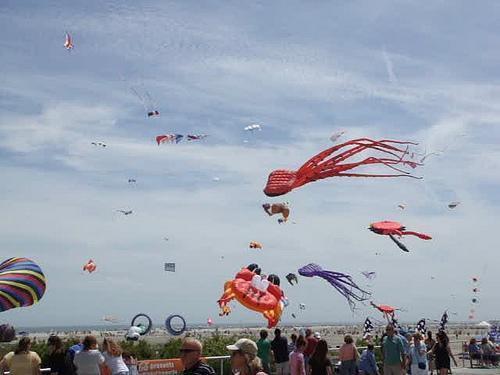How many squid kites are there?
Give a very brief answer. 2. How many squid-shaped kites can be seen?
Give a very brief answer. 2. 